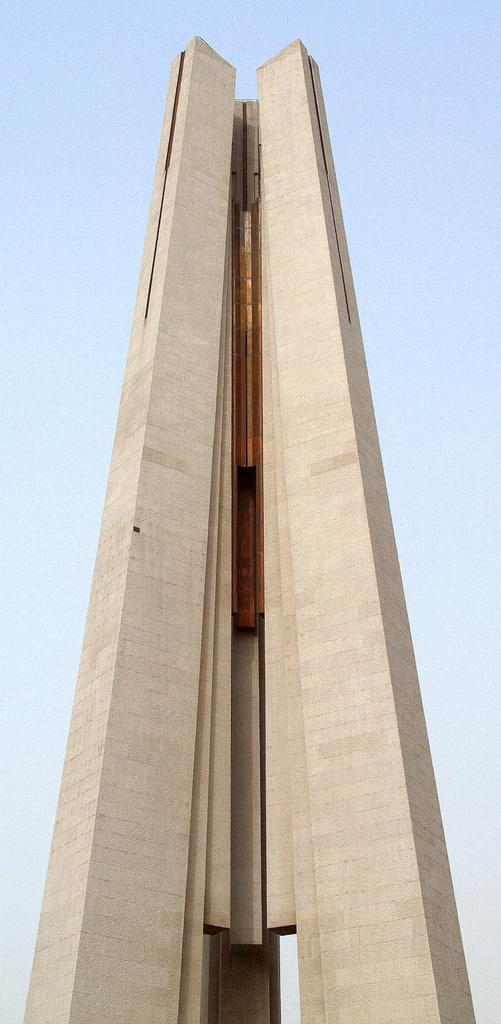What is the main subject in the center of the image? There is a building in the center of the image. What can be seen in the background of the image? The sky is visible in the background of the image. How many legs does the frog have in the image? There is no frog present in the image, so it is not possible to determine the number of legs it might have. 